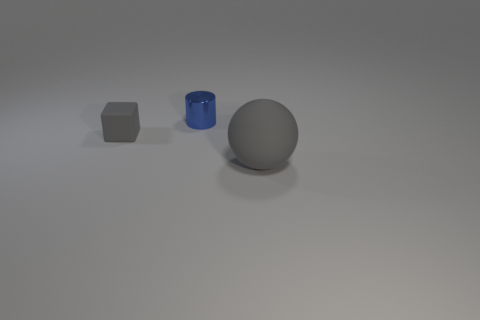Add 3 small purple cylinders. How many objects exist? 6 Subtract all balls. How many objects are left? 2 Add 1 small blue shiny objects. How many small blue shiny objects exist? 2 Subtract 0 blue cubes. How many objects are left? 3 Subtract all blue things. Subtract all large purple things. How many objects are left? 2 Add 1 big gray matte objects. How many big gray matte objects are left? 2 